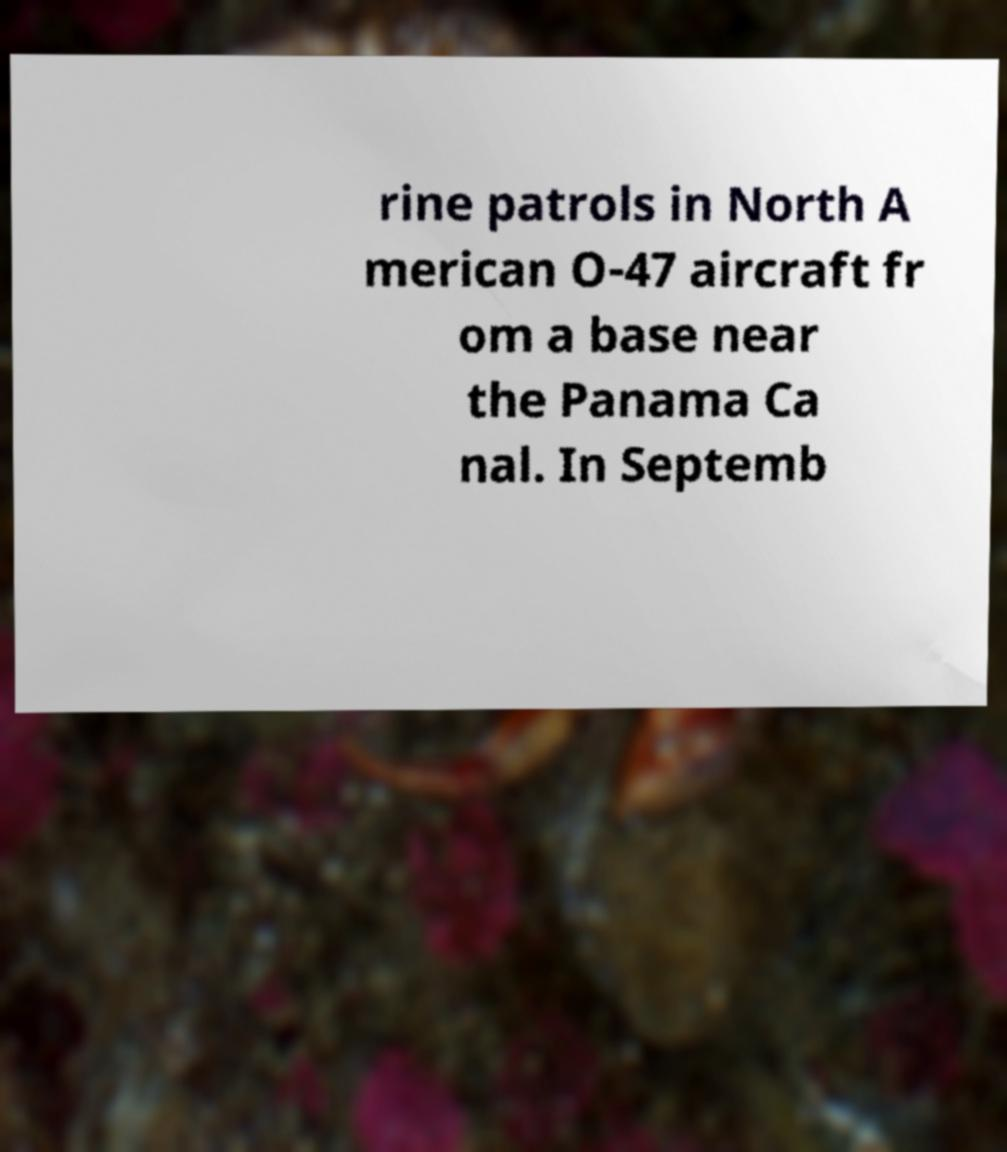What messages or text are displayed in this image? I need them in a readable, typed format. rine patrols in North A merican O-47 aircraft fr om a base near the Panama Ca nal. In Septemb 